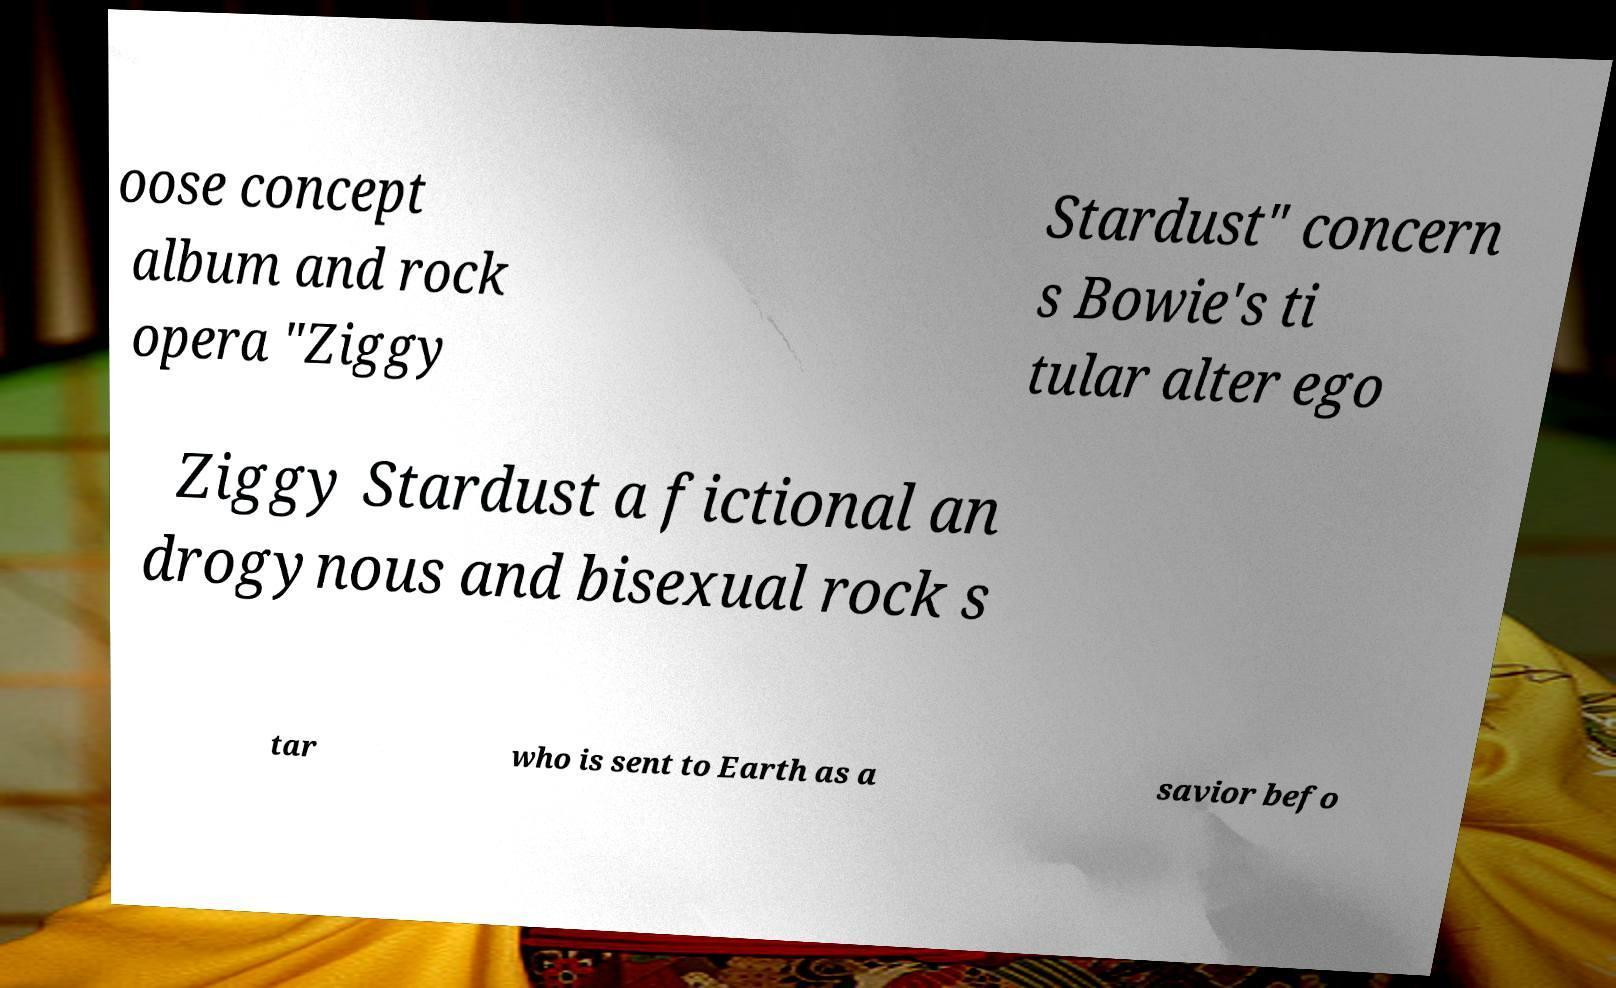I need the written content from this picture converted into text. Can you do that? oose concept album and rock opera "Ziggy Stardust" concern s Bowie's ti tular alter ego Ziggy Stardust a fictional an drogynous and bisexual rock s tar who is sent to Earth as a savior befo 